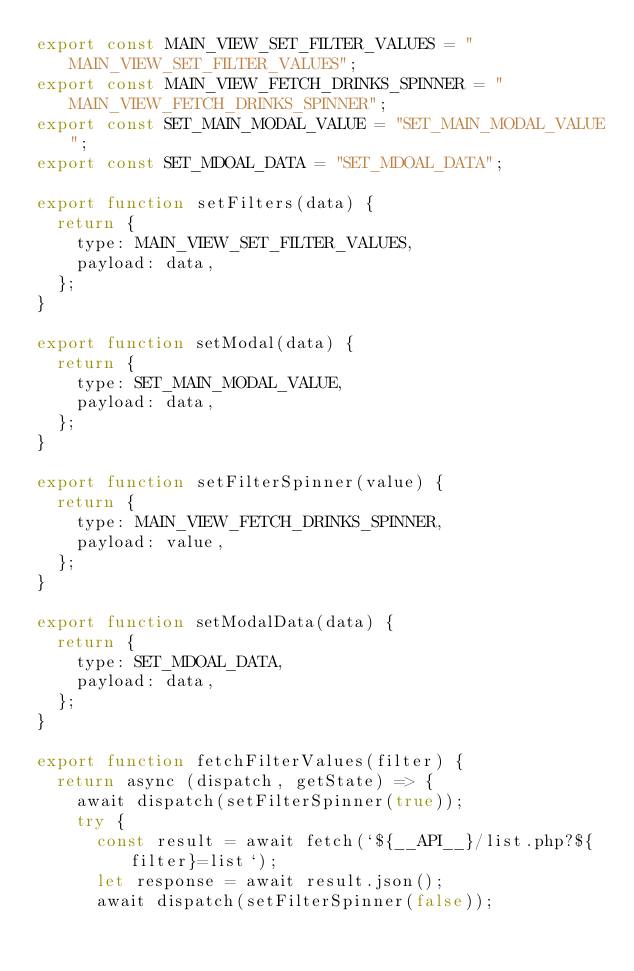<code> <loc_0><loc_0><loc_500><loc_500><_JavaScript_>export const MAIN_VIEW_SET_FILTER_VALUES = "MAIN_VIEW_SET_FILTER_VALUES";
export const MAIN_VIEW_FETCH_DRINKS_SPINNER = "MAIN_VIEW_FETCH_DRINKS_SPINNER";
export const SET_MAIN_MODAL_VALUE = "SET_MAIN_MODAL_VALUE";
export const SET_MDOAL_DATA = "SET_MDOAL_DATA";

export function setFilters(data) {
  return {
    type: MAIN_VIEW_SET_FILTER_VALUES,
    payload: data,
  };
}

export function setModal(data) {
  return {
    type: SET_MAIN_MODAL_VALUE,
    payload: data,
  };
}

export function setFilterSpinner(value) {
  return {
    type: MAIN_VIEW_FETCH_DRINKS_SPINNER,
    payload: value,
  };
}

export function setModalData(data) {
  return {
    type: SET_MDOAL_DATA,
    payload: data,
  };
}

export function fetchFilterValues(filter) {
  return async (dispatch, getState) => {
    await dispatch(setFilterSpinner(true));
    try {
      const result = await fetch(`${__API__}/list.php?${filter}=list`);
      let response = await result.json();
      await dispatch(setFilterSpinner(false));</code> 